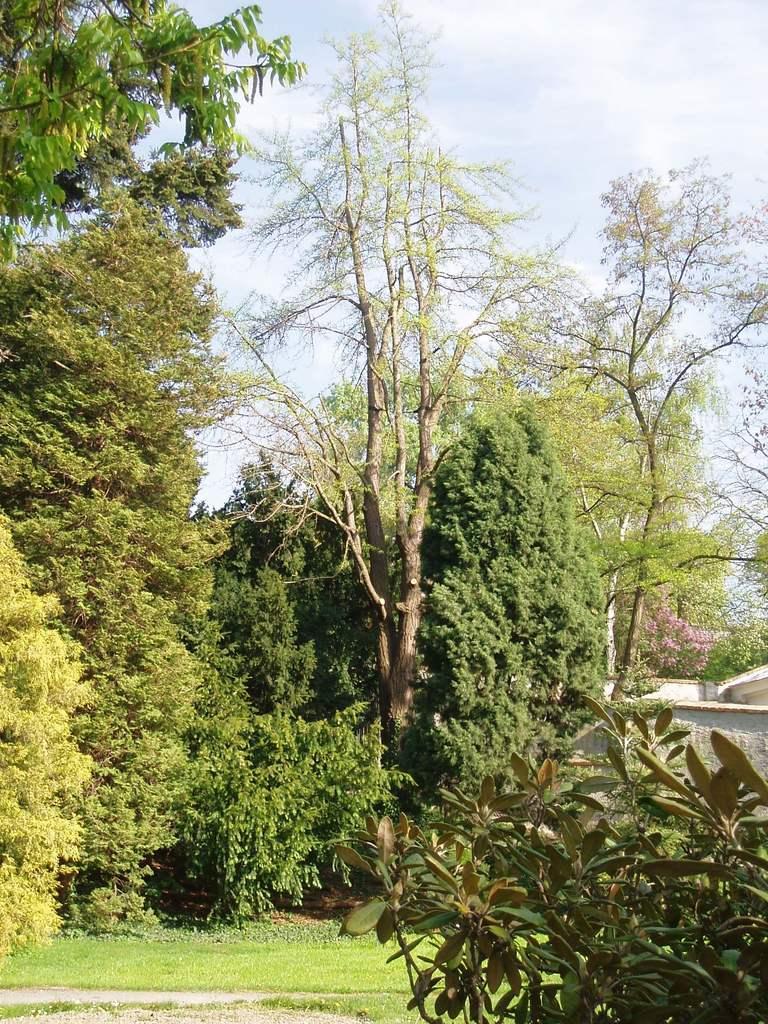Could you give a brief overview of what you see in this image? On the right side of the image there is a plant. There is a building. At the bottom of the image there is grass on the surface. In the background of the image there are trees and sky. 